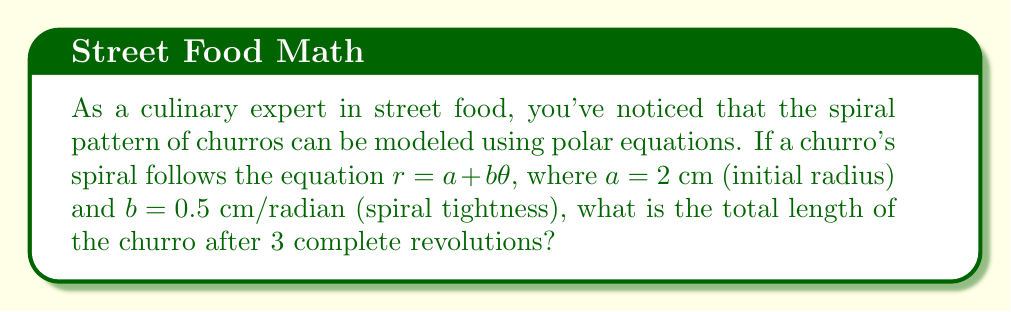Could you help me with this problem? Let's approach this step-by-step:

1) The polar equation for the churro spiral is given as $r = a + b\theta$, where:
   $a = 2$ cm (initial radius)
   $b = 0.5$ cm/radian (spiral tightness)
   
2) For 3 complete revolutions, $\theta$ goes from 0 to $6\pi$ radians.

3) To find the length of a polar curve, we use the arc length formula:

   $$L = \int_0^{\theta} \sqrt{r^2 + \left(\frac{dr}{d\theta}\right)^2} d\theta$$

4) For our equation $r = a + b\theta$:
   $\frac{dr}{d\theta} = b = 0.5$

5) Substituting into the arc length formula:

   $$L = \int_0^{6\pi} \sqrt{(2 + 0.5\theta)^2 + 0.5^2} d\theta$$

6) This integral is complex to solve analytically. We can use numerical integration methods or a computer algebra system to evaluate it.

7) Using a numerical integration method, we find:

   $$L \approx 59.07 \text{ cm}$$

This represents the approximate total length of the churro after 3 complete revolutions.
Answer: $59.07$ cm 